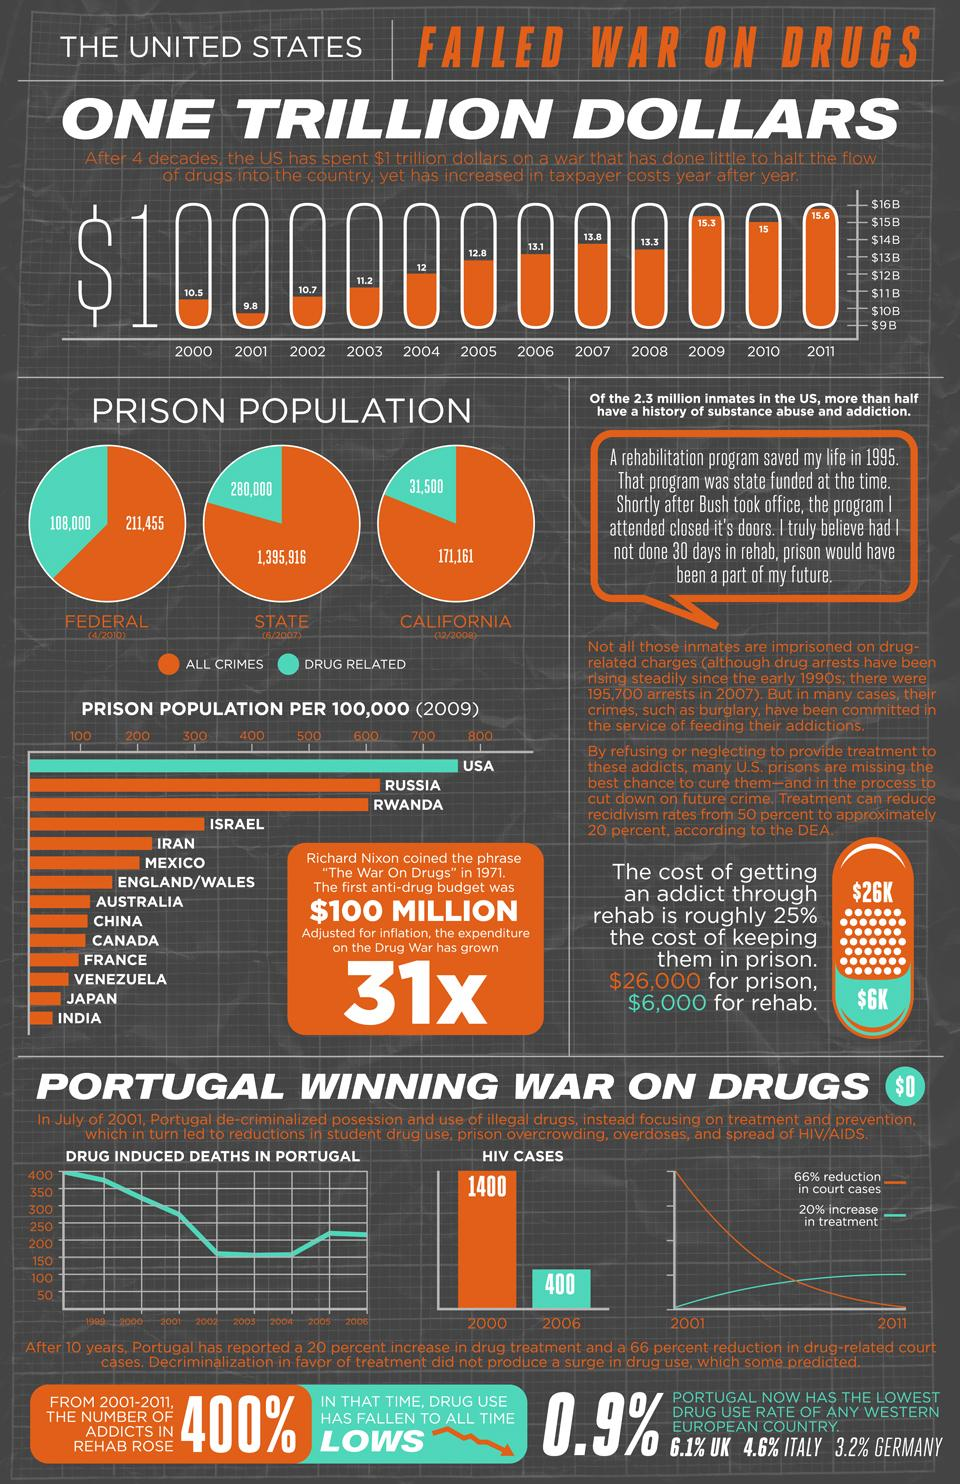Point out several critical features in this image. As of the current date, the prison population in the state for all crimes stands at 1,395,916 individuals. According to statistics, in California, there are approximately 31,500 individuals currently incarcerated for drug-related crimes. The expense on the war on drugs has grown by 31 times. From 2000 to 2006, there was a significant decrease in the number of reported cases of HIV. For 40 years, the war on drugs has been ongoing. 